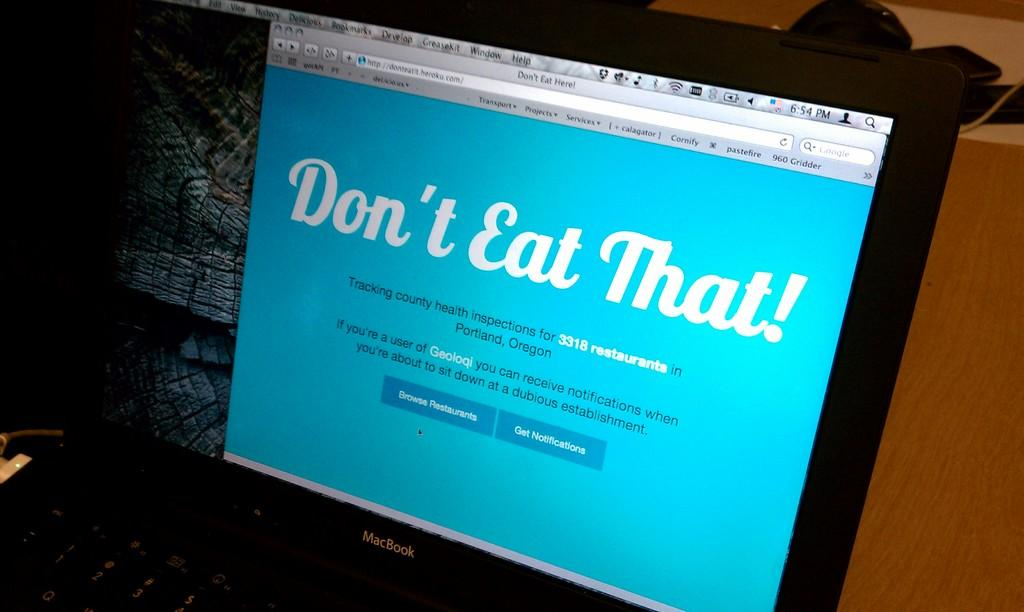<image>
Summarize the visual content of the image. A laptop open to a webpage telling the user "Don't Eat That!" 